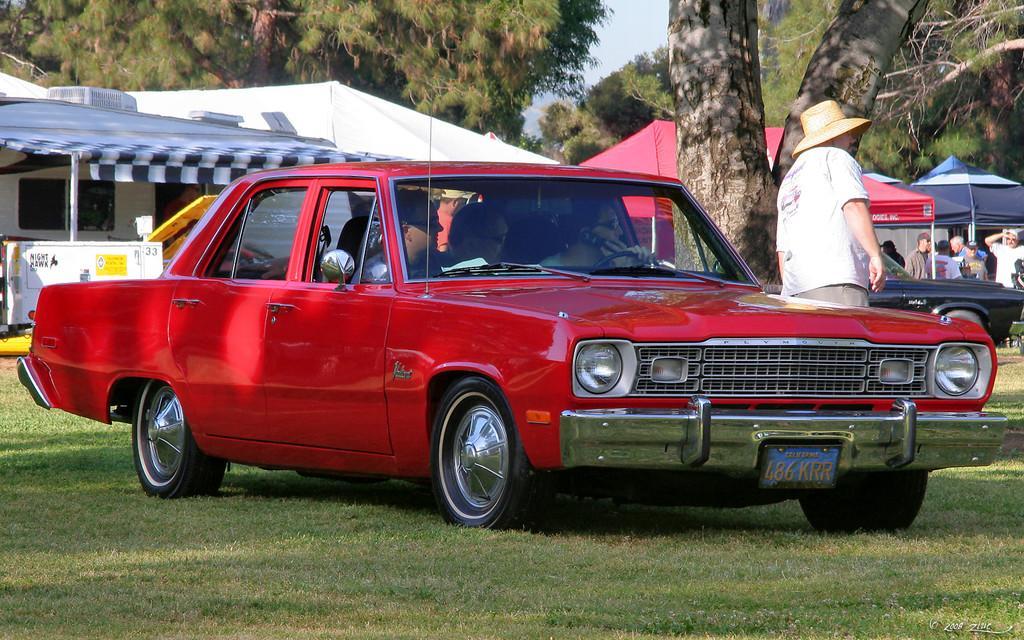In one or two sentences, can you explain what this image depicts? Few people are sitting in a red color car. There is man standing beside the car with a hat. There is tree beside him. There are some talents,people beside cars and trees in the background. 